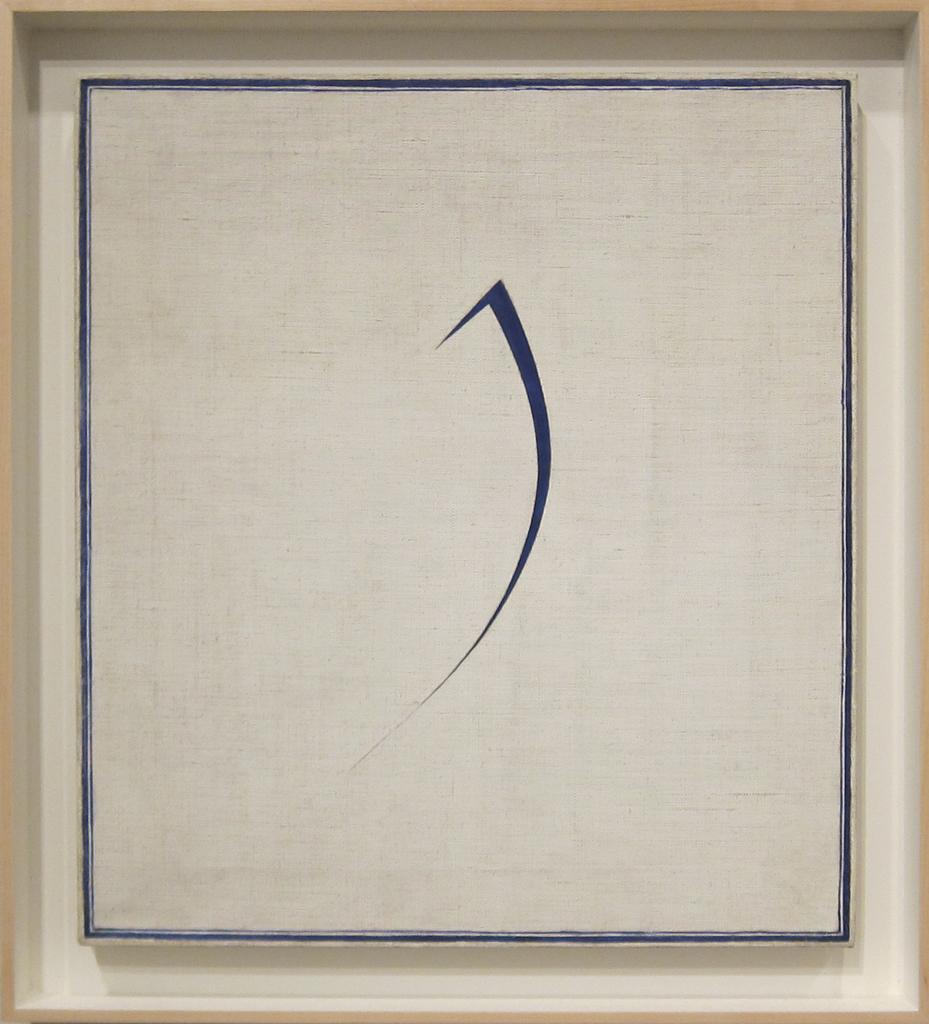What type of artwork is depicted in the image? The image appears to be a painting. What type of trouble is the dog causing in the painting? There is no dog present in the image, and therefore no trouble can be observed. How much sugar is visible in the painting? There is no sugar present in the image, as it is a painting and not a physical scene. 